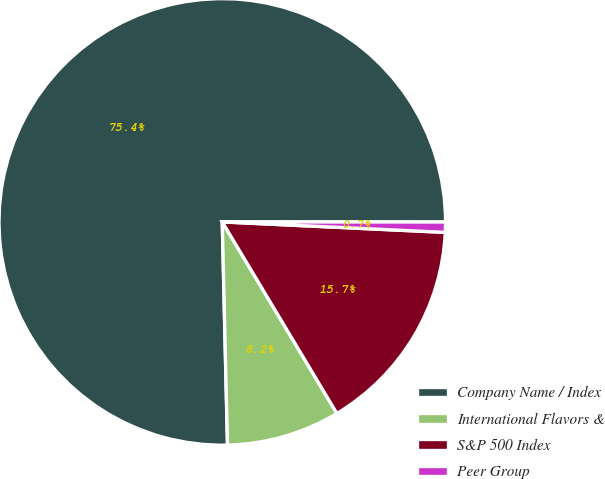Convert chart to OTSL. <chart><loc_0><loc_0><loc_500><loc_500><pie_chart><fcel>Company Name / Index<fcel>International Flavors &<fcel>S&P 500 Index<fcel>Peer Group<nl><fcel>75.38%<fcel>8.21%<fcel>15.67%<fcel>0.74%<nl></chart> 